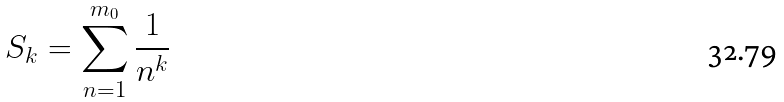<formula> <loc_0><loc_0><loc_500><loc_500>S _ { k } = \sum _ { n = 1 } ^ { m _ { 0 } } \frac { 1 } { n ^ { k } }</formula> 